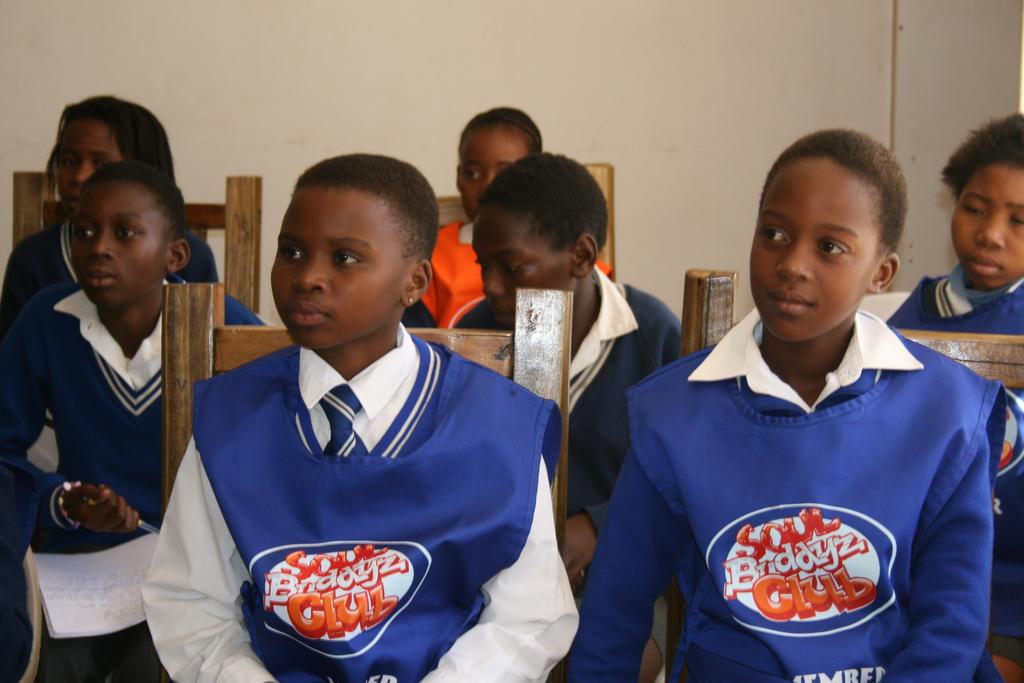What is the main subject of the image? The main subject of the image is a group of children. What are the children doing in the image? The children are sitting on chairs in the image. What can be seen in the background of the image? There is a wall in the background of the image. Can you describe the person on the left side of the image? There is a person holding a pen on the left side of the image. What type of cabbage is being used as a hat by one of the children in the image? There is no cabbage present in the image, and no child is wearing a cabbage as a hat. 